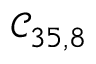Convert formula to latex. <formula><loc_0><loc_0><loc_500><loc_500>\mathcal { C } _ { 3 5 , 8 }</formula> 